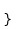Convert code to text. <code><loc_0><loc_0><loc_500><loc_500><_TypeScript_>}
</code> 